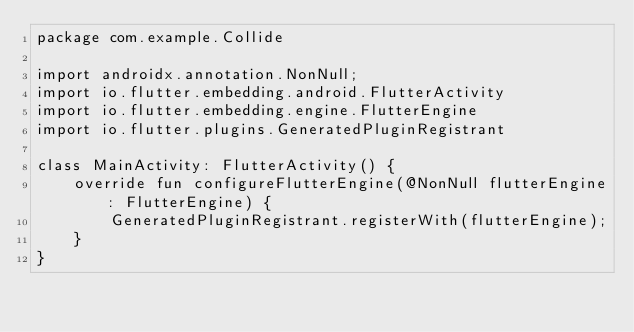Convert code to text. <code><loc_0><loc_0><loc_500><loc_500><_Kotlin_>package com.example.Collide

import androidx.annotation.NonNull;
import io.flutter.embedding.android.FlutterActivity
import io.flutter.embedding.engine.FlutterEngine
import io.flutter.plugins.GeneratedPluginRegistrant

class MainActivity: FlutterActivity() {
    override fun configureFlutterEngine(@NonNull flutterEngine: FlutterEngine) {
        GeneratedPluginRegistrant.registerWith(flutterEngine);
    }
}
</code> 